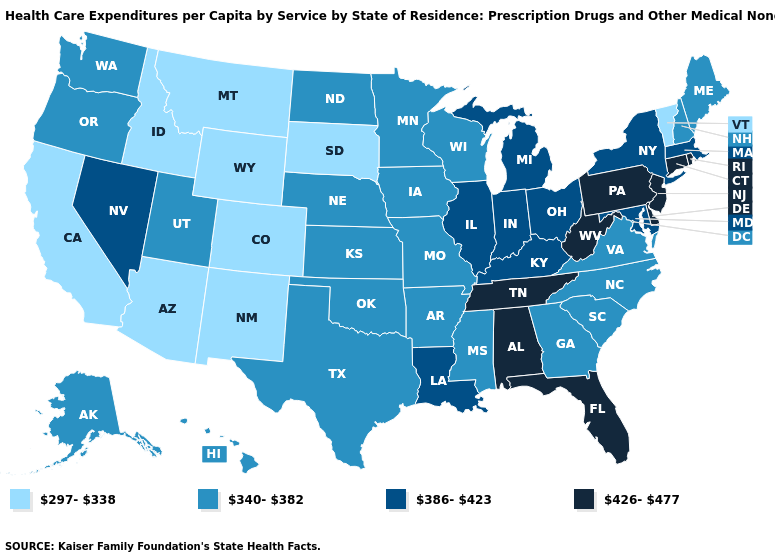Does the first symbol in the legend represent the smallest category?
Give a very brief answer. Yes. Does Indiana have the same value as Vermont?
Short answer required. No. What is the value of Texas?
Give a very brief answer. 340-382. What is the value of Florida?
Give a very brief answer. 426-477. Among the states that border Oregon , does Idaho have the lowest value?
Answer briefly. Yes. Among the states that border Kentucky , which have the highest value?
Answer briefly. Tennessee, West Virginia. Name the states that have a value in the range 426-477?
Answer briefly. Alabama, Connecticut, Delaware, Florida, New Jersey, Pennsylvania, Rhode Island, Tennessee, West Virginia. What is the value of Maryland?
Give a very brief answer. 386-423. Name the states that have a value in the range 386-423?
Keep it brief. Illinois, Indiana, Kentucky, Louisiana, Maryland, Massachusetts, Michigan, Nevada, New York, Ohio. Name the states that have a value in the range 340-382?
Short answer required. Alaska, Arkansas, Georgia, Hawaii, Iowa, Kansas, Maine, Minnesota, Mississippi, Missouri, Nebraska, New Hampshire, North Carolina, North Dakota, Oklahoma, Oregon, South Carolina, Texas, Utah, Virginia, Washington, Wisconsin. What is the highest value in the USA?
Be succinct. 426-477. What is the highest value in the USA?
Answer briefly. 426-477. Does Nevada have a higher value than Alabama?
Answer briefly. No. What is the lowest value in the USA?
Be succinct. 297-338. 